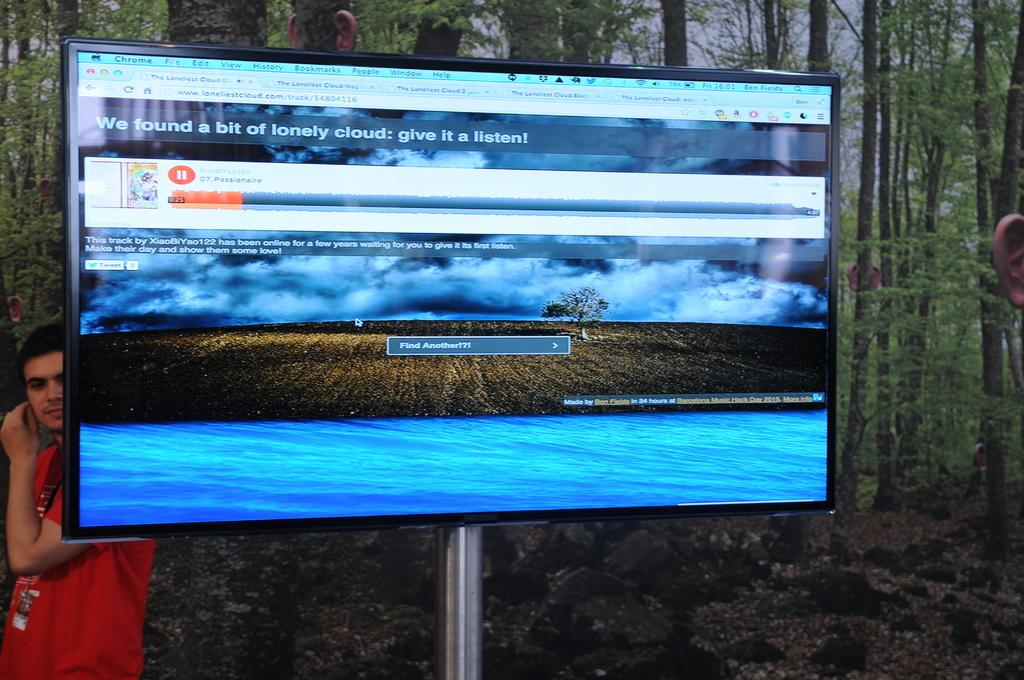<image>
Write a terse but informative summary of the picture. A television screen shows that the song Passionaire is playing. 